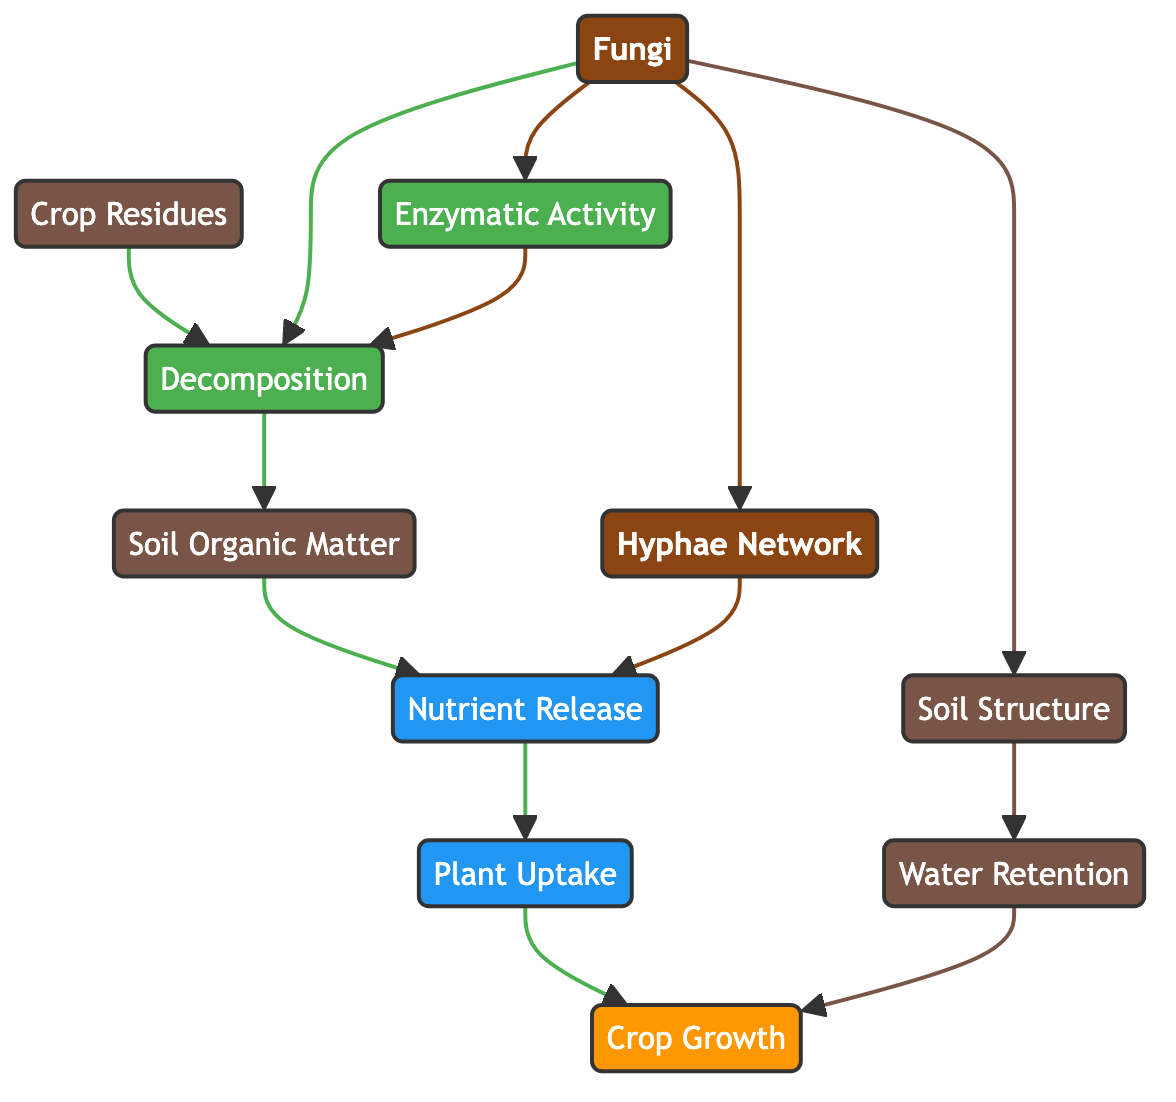What's the total number of nodes in the diagram? The diagram lists a total of 11 unique entities, which are the nodes: Fungi, Soil Organic Matter, Crop Residues, Decomposition, Nutrient Release, Plant Uptake, Crop Growth, Hyphae Network, Enzymatic Activity, Soil Structure, and Water Retention. Therefore, counting each of these gives us a total of 11 nodes.
Answer: 11 How many edges are present in the diagram? By examining the connections between the nodes in the diagram, we can identify a total of 13 directed edges, each representing a specific relationship or flow of processes mediated by fungi.
Answer: 13 What is the relationship between Fungi and Decomposition? The directed edge from Fungi to Decomposition indicates that fungi mediate or play a role in the decomposition process, facilitating the breakdown of organic materials, including crop residues.
Answer: Fungi contribute to Decomposition Which node directly follows Nutrient Release in the cycle? Following the directed edge from Nutrient Release, the next node in the cycle is Plant Uptake. This indicates that the nutrients released from organic matter are subsequently taken up by plants for their growth.
Answer: Plant Uptake What effect does Soil Structure have on Crop Growth? The diagram shows a direct connection from Soil Structure to Water Retention, and then from Water Retention to Crop Growth. This means that improvements in soil structure positively impact water retention, which in turn enhances crop growth.
Answer: Enhances Crop Growth How do Enzymatic Activity and Decomposition interact? There is a directed edge from Enzymatic Activity to Decomposition, indicating that enzymatic activity is an essential process that promotes decomposition, effectively breaking down materials to enhance nutrient cycling in the agroecosystem.
Answer: Enzymatic Activity promotes Decomposition What is the role of the Hyphae Network in nutrient cycling? The Hyphae Network connects directly to Nutrient Release in the diagram. This relationship implies that the hyphal structures of fungi facilitate the release of nutrients back into the soil, playing a crucial role in nutrient cycling within agroecosystems.
Answer: Facilitates Nutrient Release What is the final outcome of the processes represented in the diagram? Tracing the flow from Fungi through to Crop Growth, the final outcome of these interconnected processes—starting from decomposition and nutrient release, leading to plant uptake—is ultimately an increase in crop growth. Therefore, the overarching goal illustrated is the enhancement of crop productivity through these cycles.
Answer: Crop Growth 